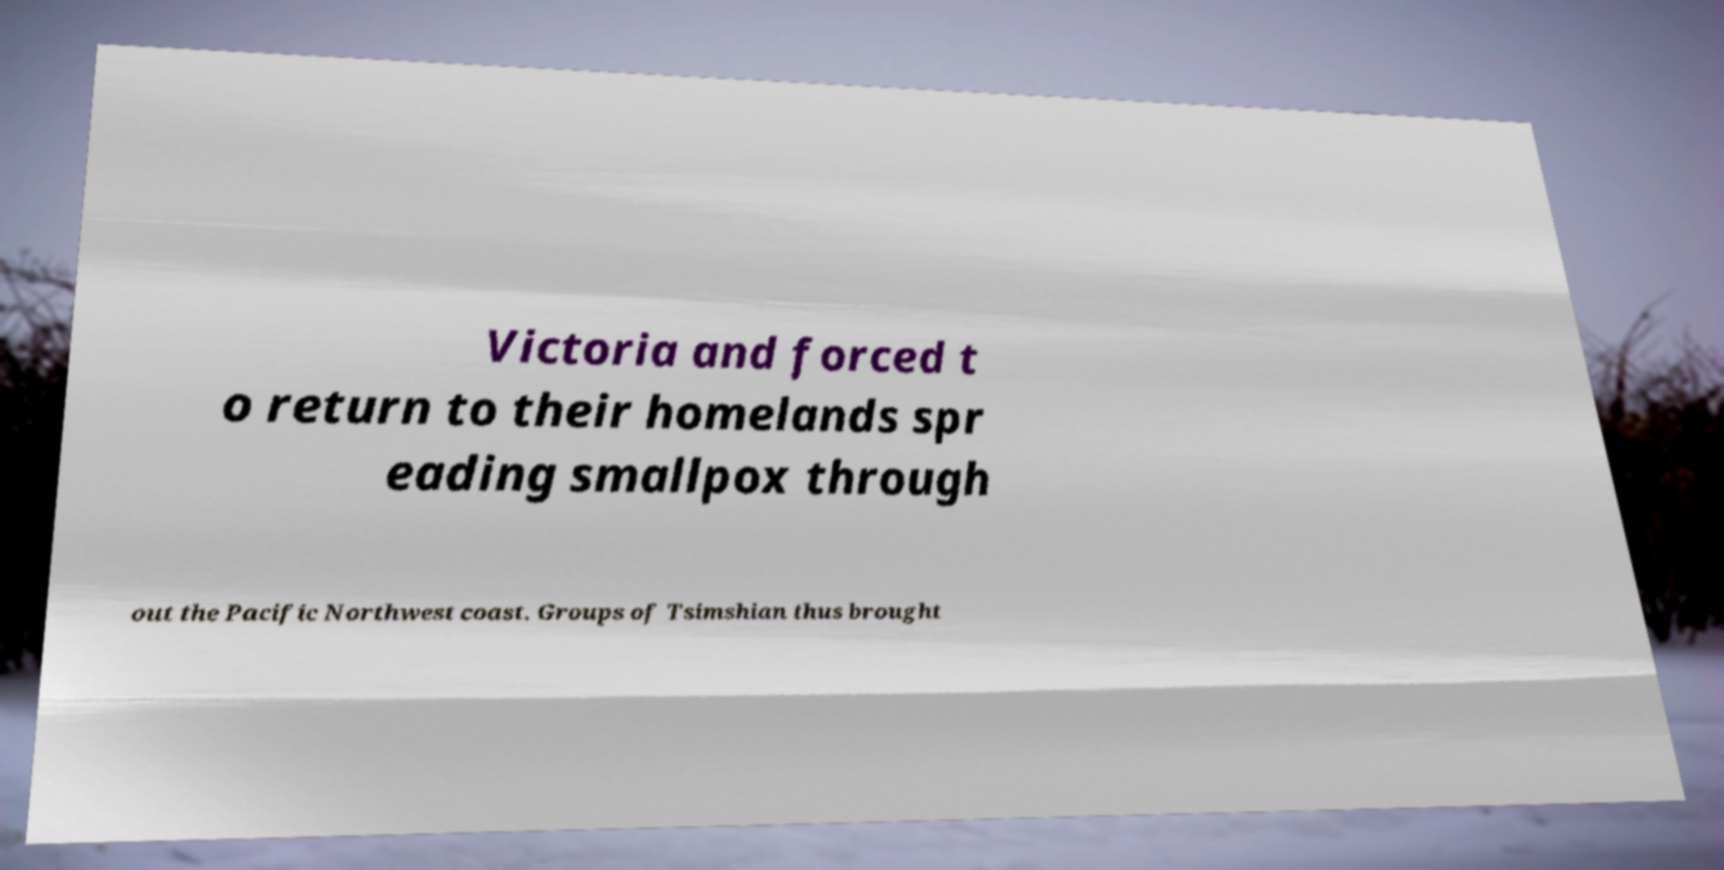There's text embedded in this image that I need extracted. Can you transcribe it verbatim? Victoria and forced t o return to their homelands spr eading smallpox through out the Pacific Northwest coast. Groups of Tsimshian thus brought 